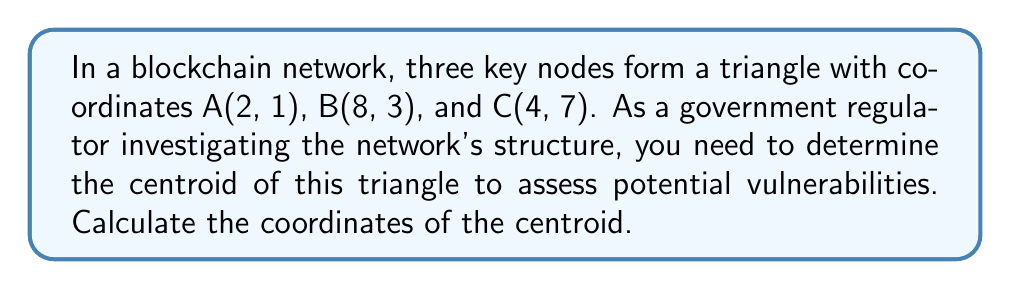Show me your answer to this math problem. To find the centroid of a triangle, we need to follow these steps:

1. The centroid of a triangle is located at the intersection of its medians. Each median connects a vertex to the midpoint of the opposite side.

2. The centroid divides each median in a 2:1 ratio, with the longer segment closer to the vertex.

3. The coordinates of the centroid can be calculated using the formula:

   $$\left(\frac{x_1 + x_2 + x_3}{3}, \frac{y_1 + y_2 + y_3}{3}\right)$$

   where $(x_1, y_1)$, $(x_2, y_2)$, and $(x_3, y_3)$ are the coordinates of the three vertices.

4. Let's substitute the given coordinates into the formula:

   $$\left(\frac{2 + 8 + 4}{3}, \frac{1 + 3 + 7}{3}\right)$$

5. Simplify:

   $$\left(\frac{14}{3}, \frac{11}{3}\right)$$

6. The result can be left as fractions or converted to decimals:

   $$(4.\overline{6}, 3.\overline{6})$$

[asy]
unitsize(1cm);
pair A = (2,1), B = (8,3), C = (4,7);
pair G = (14/3, 11/3);
draw(A--B--C--cycle);
draw(A--G,dashed);
draw(B--G,dashed);
draw(C--G,dashed);
dot("A (2,1)", A, SW);
dot("B (8,3)", B, SE);
dot("C (4,7)", C, N);
dot("G", G, NE);
[/asy]
Answer: $(4.\overline{6}, 3.\overline{6})$ or $(\frac{14}{3}, \frac{11}{3})$ 